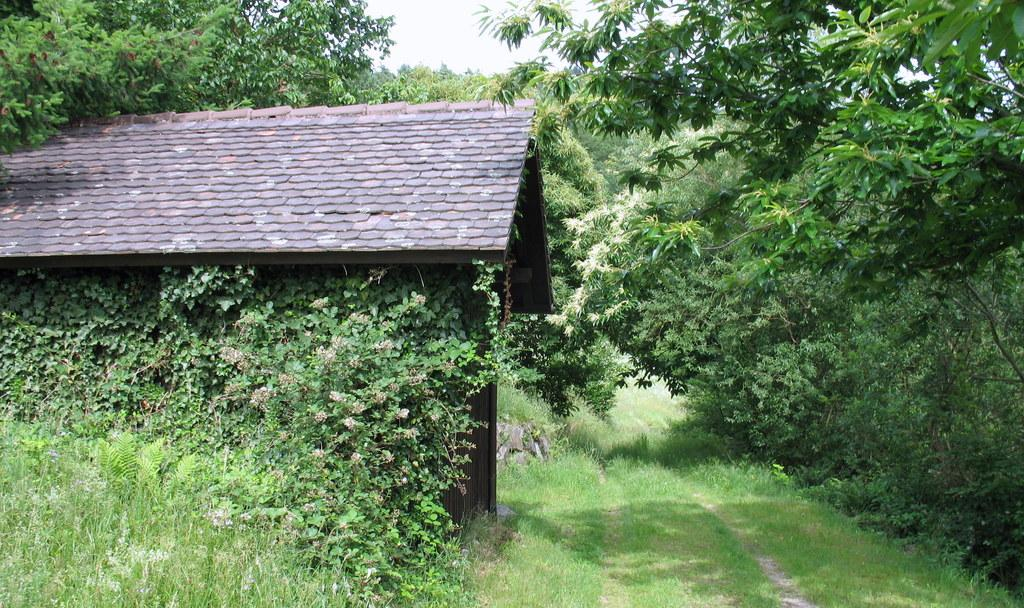What type of structure is visible in the image? There is a building in the image. What type of vegetation can be seen in the image? There are plants, trees, and grass visible in the image. How many ants are crawling on the farm in the image? There is no farm or ants present in the image. What type of knowledge is being shared in the image? There is no indication of knowledge being shared in the image. 